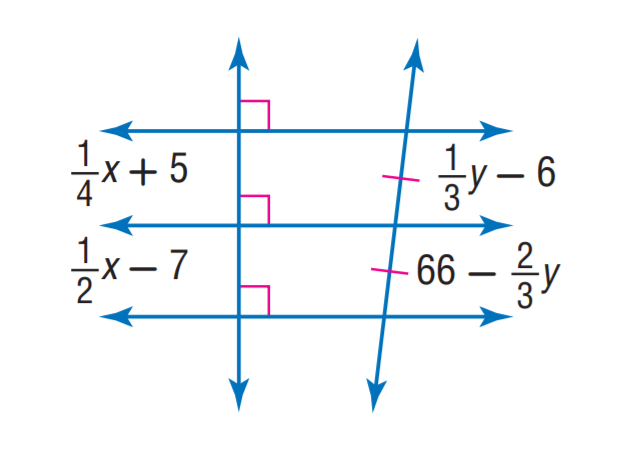Answer the mathemtical geometry problem and directly provide the correct option letter.
Question: Find y.
Choices: A: 36 B: 48 C: 66 D: 72 D 